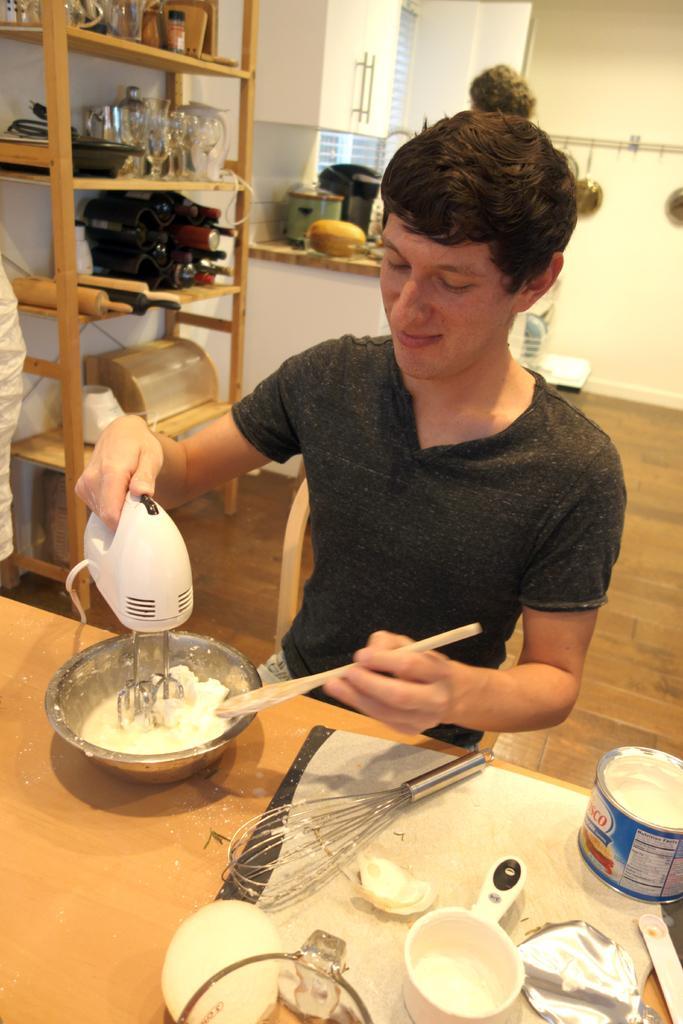Please provide a concise description of this image. In this picture there is a man sitting and holding the spoon and machine and there is a spoon, box and there are objects on the table. At the back there are glasses and there are objects in the shelf and there are utensils on the table and there are utensils hanging on the wall and there is a window and cupboard. At the bottom there is a floor. 